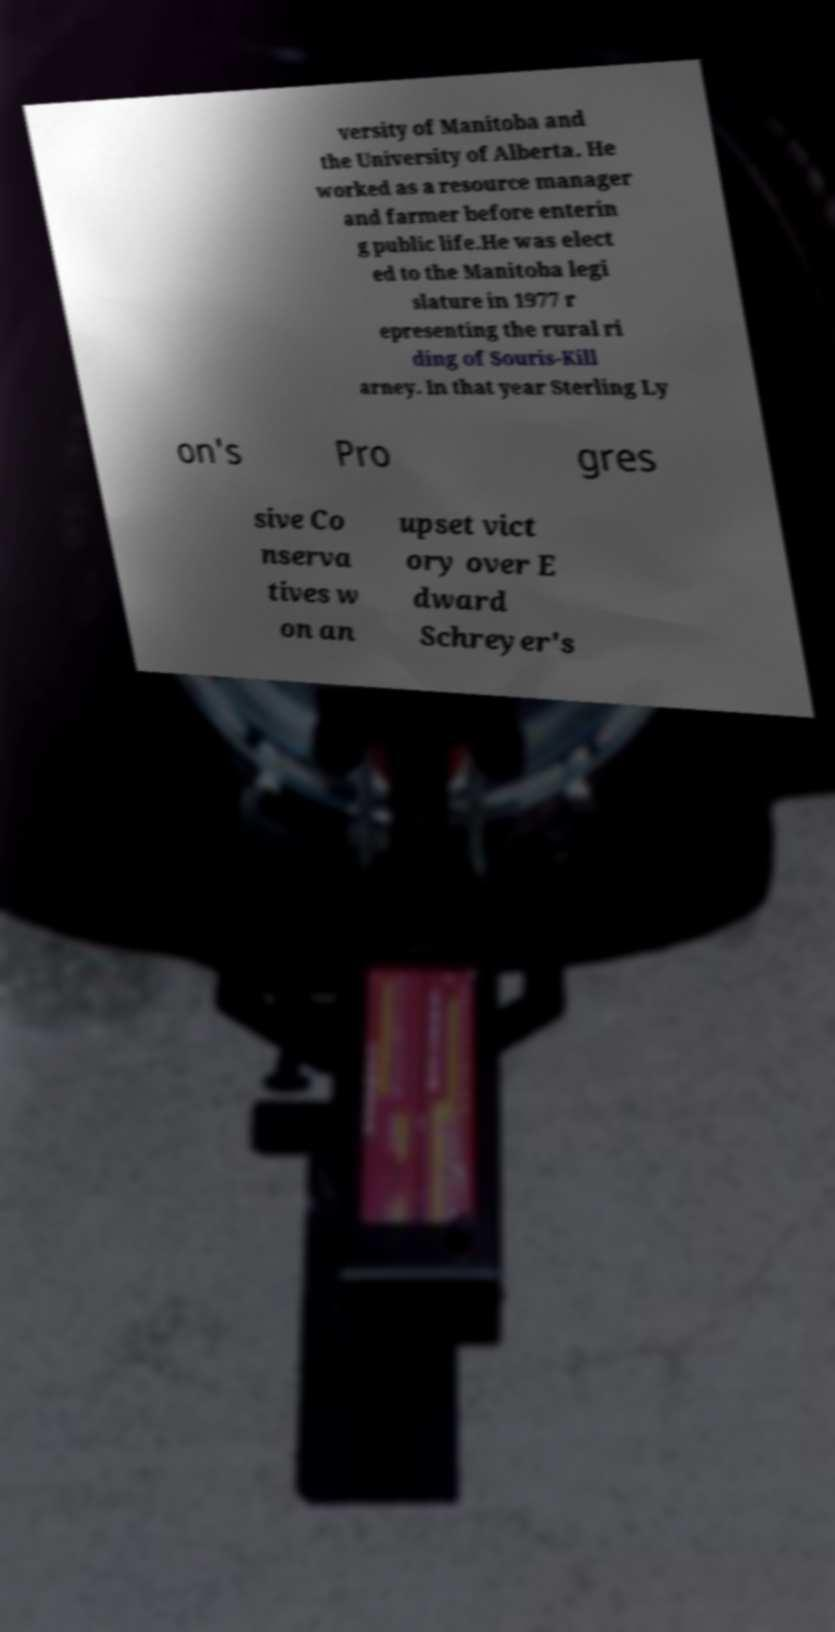Could you extract and type out the text from this image? versity of Manitoba and the University of Alberta. He worked as a resource manager and farmer before enterin g public life.He was elect ed to the Manitoba legi slature in 1977 r epresenting the rural ri ding of Souris-Kill arney. In that year Sterling Ly on's Pro gres sive Co nserva tives w on an upset vict ory over E dward Schreyer's 